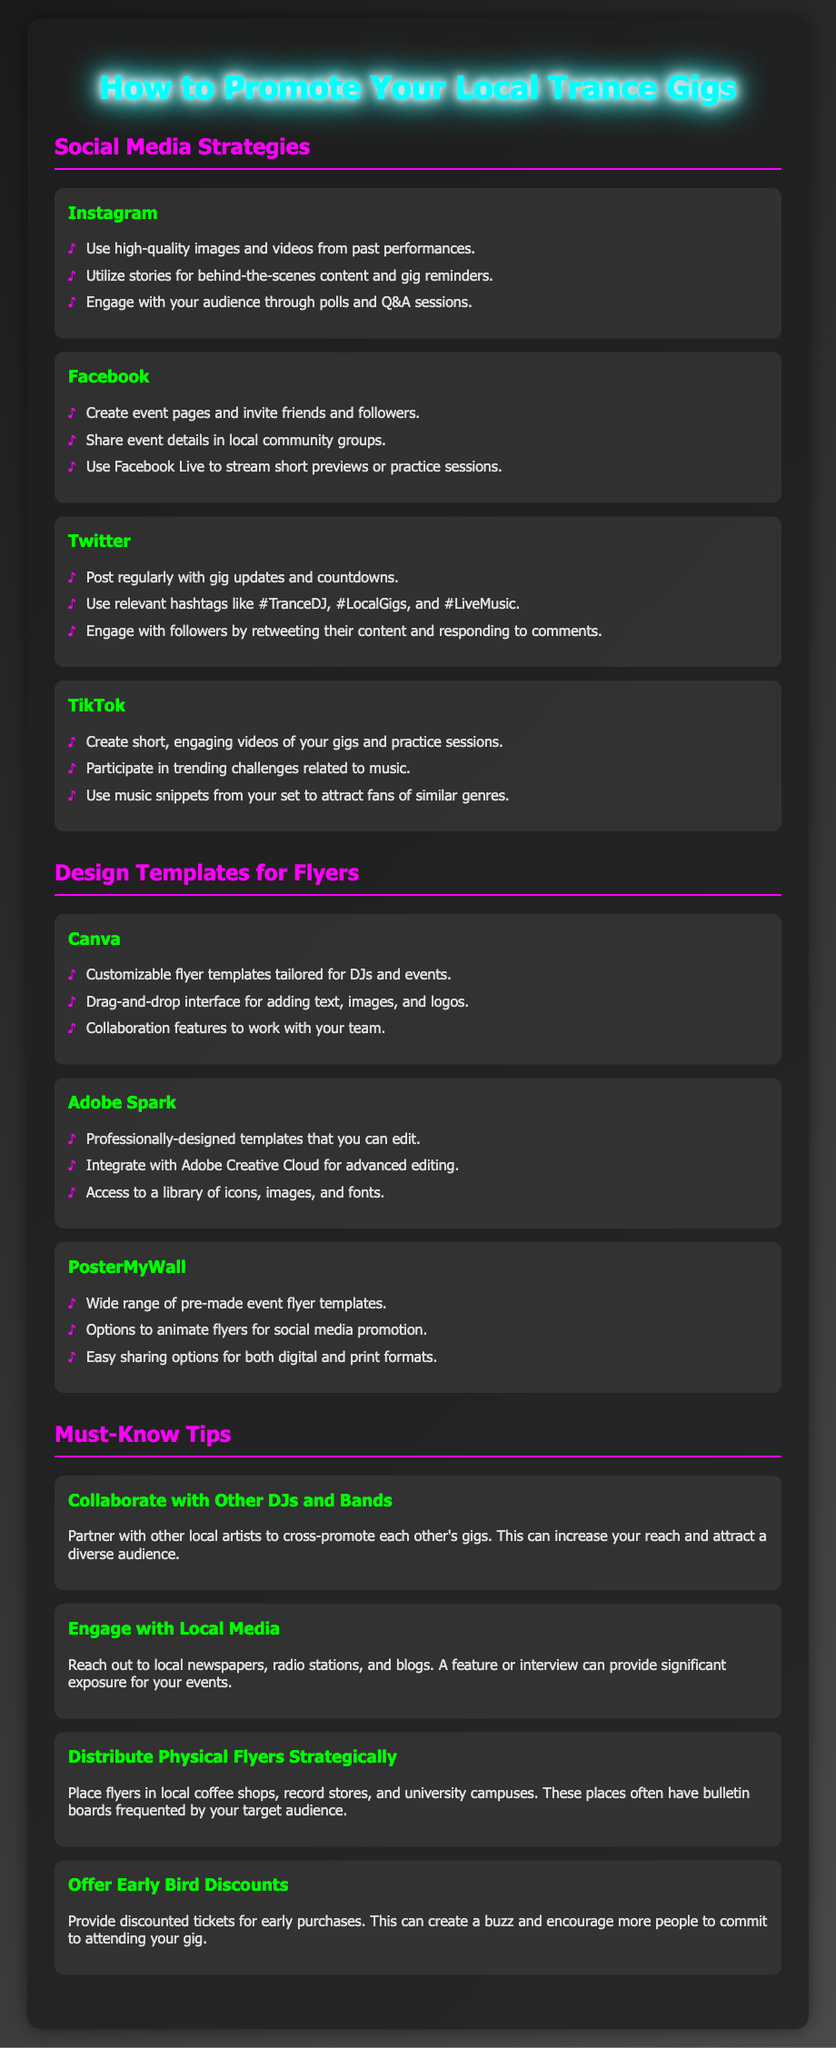What are effective platforms for promoting gigs? The platforms listed for promoting gigs are Instagram, Facebook, Twitter, and TikTok.
Answer: Instagram, Facebook, Twitter, TikTok What should you use on Instagram for promoting? The document suggests using high-quality images and videos, stories, and engaging content like polls on Instagram.
Answer: High-quality images and videos Which tool provides customizable flyer templates? Canva is mentioned as a tool that offers customizable flyer templates for DJs and events.
Answer: Canva What is a must-know tip for engaging with local media? The document emphasizes reaching out to local newspapers, radio stations, and blogs for significant exposure.
Answer: Reach out to local newspapers What should you do to encourage early attendance? Offering discounted tickets for early purchases is recommended to create a buzz and encourage attendance.
Answer: Offer early bird discounts What are the design tools mentioned for flyer creation? The document lists Canva, Adobe Spark, and PosterMyWall as design tools for flyers.
Answer: Canva, Adobe Spark, PosterMyWall How can collaborating with other artists help your gigs? Partnering with other local artists can increase your reach and attract a diverse audience.
Answer: Increase your reach What type of video content is suggested for TikTok? Short, engaging videos of gigs and practice sessions are recommended for TikTok.
Answer: Short, engaging videos What is the benefit of distributing physical flyers? Placing flyers in strategic locations helps reach your target audience effectively.
Answer: Reach your target audience 